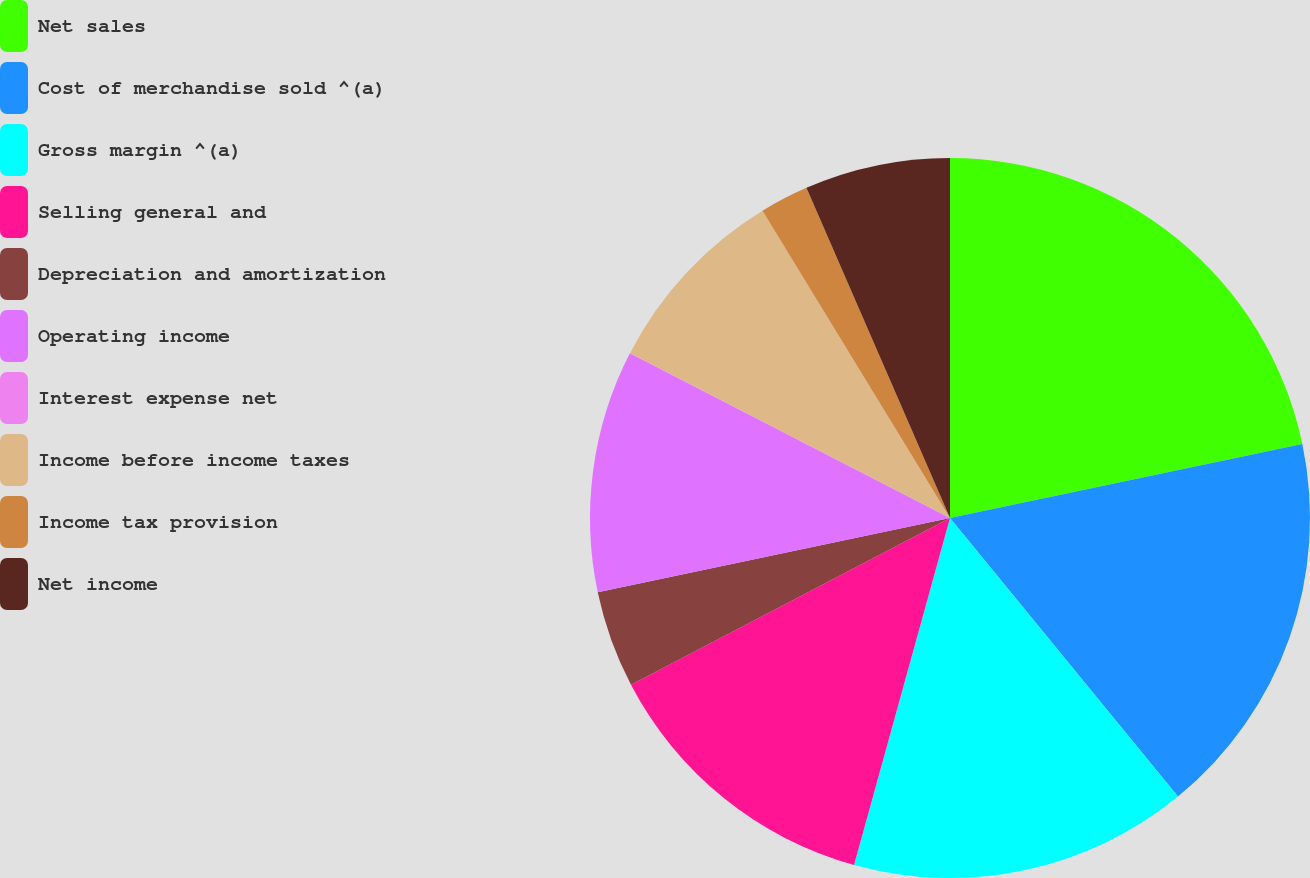Convert chart. <chart><loc_0><loc_0><loc_500><loc_500><pie_chart><fcel>Net sales<fcel>Cost of merchandise sold ^(a)<fcel>Gross margin ^(a)<fcel>Selling general and<fcel>Depreciation and amortization<fcel>Operating income<fcel>Interest expense net<fcel>Income before income taxes<fcel>Income tax provision<fcel>Net income<nl><fcel>21.71%<fcel>17.38%<fcel>15.21%<fcel>13.04%<fcel>4.36%<fcel>10.87%<fcel>0.02%<fcel>8.7%<fcel>2.19%<fcel>6.53%<nl></chart> 